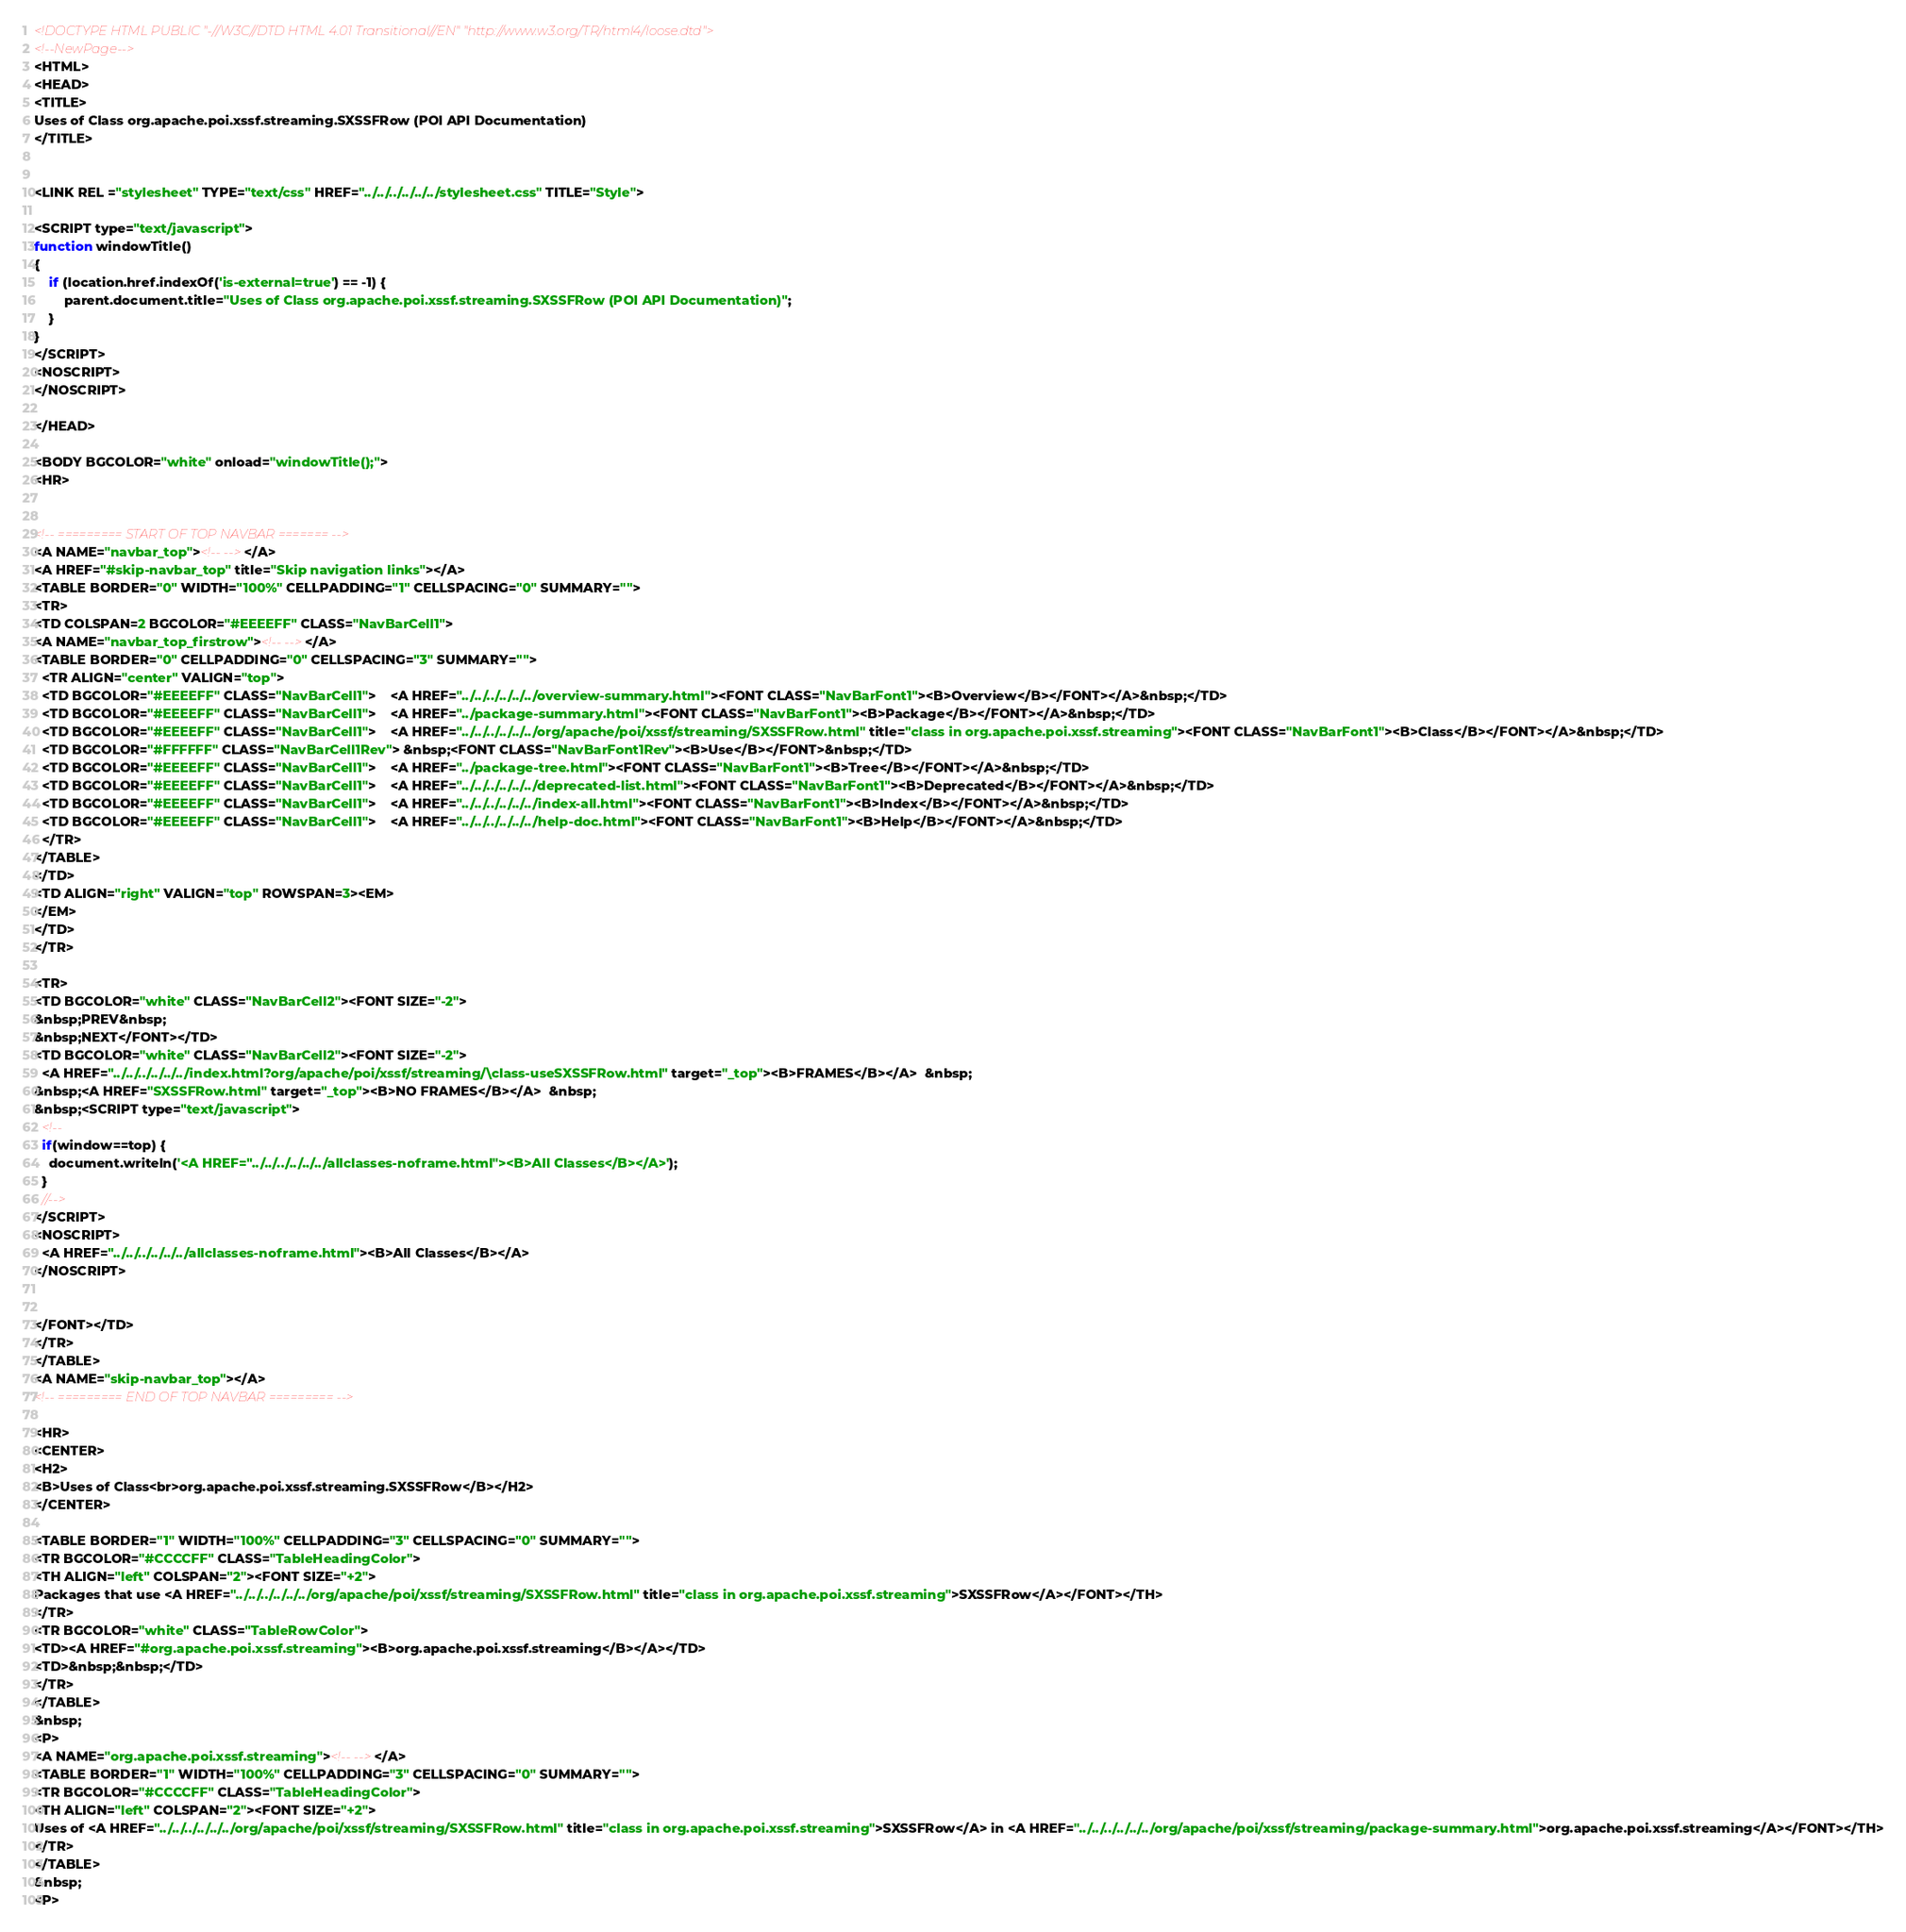Convert code to text. <code><loc_0><loc_0><loc_500><loc_500><_HTML_><!DOCTYPE HTML PUBLIC "-//W3C//DTD HTML 4.01 Transitional//EN" "http://www.w3.org/TR/html4/loose.dtd">
<!--NewPage-->
<HTML>
<HEAD>
<TITLE>
Uses of Class org.apache.poi.xssf.streaming.SXSSFRow (POI API Documentation)
</TITLE>


<LINK REL ="stylesheet" TYPE="text/css" HREF="../../../../../../stylesheet.css" TITLE="Style">

<SCRIPT type="text/javascript">
function windowTitle()
{
    if (location.href.indexOf('is-external=true') == -1) {
        parent.document.title="Uses of Class org.apache.poi.xssf.streaming.SXSSFRow (POI API Documentation)";
    }
}
</SCRIPT>
<NOSCRIPT>
</NOSCRIPT>

</HEAD>

<BODY BGCOLOR="white" onload="windowTitle();">
<HR>


<!-- ========= START OF TOP NAVBAR ======= -->
<A NAME="navbar_top"><!-- --></A>
<A HREF="#skip-navbar_top" title="Skip navigation links"></A>
<TABLE BORDER="0" WIDTH="100%" CELLPADDING="1" CELLSPACING="0" SUMMARY="">
<TR>
<TD COLSPAN=2 BGCOLOR="#EEEEFF" CLASS="NavBarCell1">
<A NAME="navbar_top_firstrow"><!-- --></A>
<TABLE BORDER="0" CELLPADDING="0" CELLSPACING="3" SUMMARY="">
  <TR ALIGN="center" VALIGN="top">
  <TD BGCOLOR="#EEEEFF" CLASS="NavBarCell1">    <A HREF="../../../../../../overview-summary.html"><FONT CLASS="NavBarFont1"><B>Overview</B></FONT></A>&nbsp;</TD>
  <TD BGCOLOR="#EEEEFF" CLASS="NavBarCell1">    <A HREF="../package-summary.html"><FONT CLASS="NavBarFont1"><B>Package</B></FONT></A>&nbsp;</TD>
  <TD BGCOLOR="#EEEEFF" CLASS="NavBarCell1">    <A HREF="../../../../../../org/apache/poi/xssf/streaming/SXSSFRow.html" title="class in org.apache.poi.xssf.streaming"><FONT CLASS="NavBarFont1"><B>Class</B></FONT></A>&nbsp;</TD>
  <TD BGCOLOR="#FFFFFF" CLASS="NavBarCell1Rev"> &nbsp;<FONT CLASS="NavBarFont1Rev"><B>Use</B></FONT>&nbsp;</TD>
  <TD BGCOLOR="#EEEEFF" CLASS="NavBarCell1">    <A HREF="../package-tree.html"><FONT CLASS="NavBarFont1"><B>Tree</B></FONT></A>&nbsp;</TD>
  <TD BGCOLOR="#EEEEFF" CLASS="NavBarCell1">    <A HREF="../../../../../../deprecated-list.html"><FONT CLASS="NavBarFont1"><B>Deprecated</B></FONT></A>&nbsp;</TD>
  <TD BGCOLOR="#EEEEFF" CLASS="NavBarCell1">    <A HREF="../../../../../../index-all.html"><FONT CLASS="NavBarFont1"><B>Index</B></FONT></A>&nbsp;</TD>
  <TD BGCOLOR="#EEEEFF" CLASS="NavBarCell1">    <A HREF="../../../../../../help-doc.html"><FONT CLASS="NavBarFont1"><B>Help</B></FONT></A>&nbsp;</TD>
  </TR>
</TABLE>
</TD>
<TD ALIGN="right" VALIGN="top" ROWSPAN=3><EM>
</EM>
</TD>
</TR>

<TR>
<TD BGCOLOR="white" CLASS="NavBarCell2"><FONT SIZE="-2">
&nbsp;PREV&nbsp;
&nbsp;NEXT</FONT></TD>
<TD BGCOLOR="white" CLASS="NavBarCell2"><FONT SIZE="-2">
  <A HREF="../../../../../../index.html?org/apache/poi/xssf/streaming/\class-useSXSSFRow.html" target="_top"><B>FRAMES</B></A>  &nbsp;
&nbsp;<A HREF="SXSSFRow.html" target="_top"><B>NO FRAMES</B></A>  &nbsp;
&nbsp;<SCRIPT type="text/javascript">
  <!--
  if(window==top) {
    document.writeln('<A HREF="../../../../../../allclasses-noframe.html"><B>All Classes</B></A>');
  }
  //-->
</SCRIPT>
<NOSCRIPT>
  <A HREF="../../../../../../allclasses-noframe.html"><B>All Classes</B></A>
</NOSCRIPT>


</FONT></TD>
</TR>
</TABLE>
<A NAME="skip-navbar_top"></A>
<!-- ========= END OF TOP NAVBAR ========= -->

<HR>
<CENTER>
<H2>
<B>Uses of Class<br>org.apache.poi.xssf.streaming.SXSSFRow</B></H2>
</CENTER>

<TABLE BORDER="1" WIDTH="100%" CELLPADDING="3" CELLSPACING="0" SUMMARY="">
<TR BGCOLOR="#CCCCFF" CLASS="TableHeadingColor">
<TH ALIGN="left" COLSPAN="2"><FONT SIZE="+2">
Packages that use <A HREF="../../../../../../org/apache/poi/xssf/streaming/SXSSFRow.html" title="class in org.apache.poi.xssf.streaming">SXSSFRow</A></FONT></TH>
</TR>
<TR BGCOLOR="white" CLASS="TableRowColor">
<TD><A HREF="#org.apache.poi.xssf.streaming"><B>org.apache.poi.xssf.streaming</B></A></TD>
<TD>&nbsp;&nbsp;</TD>
</TR>
</TABLE>
&nbsp;
<P>
<A NAME="org.apache.poi.xssf.streaming"><!-- --></A>
<TABLE BORDER="1" WIDTH="100%" CELLPADDING="3" CELLSPACING="0" SUMMARY="">
<TR BGCOLOR="#CCCCFF" CLASS="TableHeadingColor">
<TH ALIGN="left" COLSPAN="2"><FONT SIZE="+2">
Uses of <A HREF="../../../../../../org/apache/poi/xssf/streaming/SXSSFRow.html" title="class in org.apache.poi.xssf.streaming">SXSSFRow</A> in <A HREF="../../../../../../org/apache/poi/xssf/streaming/package-summary.html">org.apache.poi.xssf.streaming</A></FONT></TH>
</TR>
</TABLE>
&nbsp;
<P>
</code> 